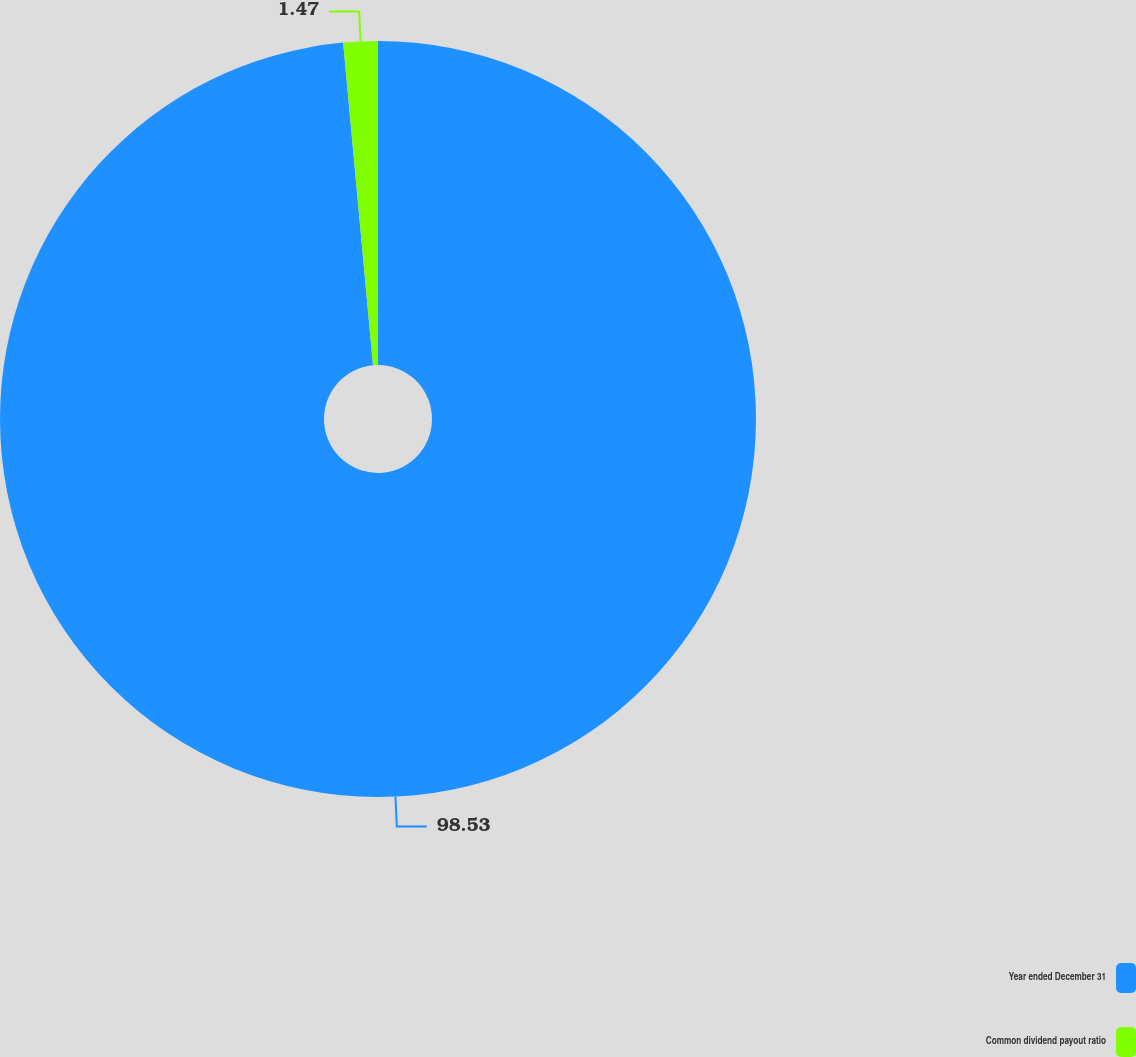Convert chart. <chart><loc_0><loc_0><loc_500><loc_500><pie_chart><fcel>Year ended December 31<fcel>Common dividend payout ratio<nl><fcel>98.53%<fcel>1.47%<nl></chart> 